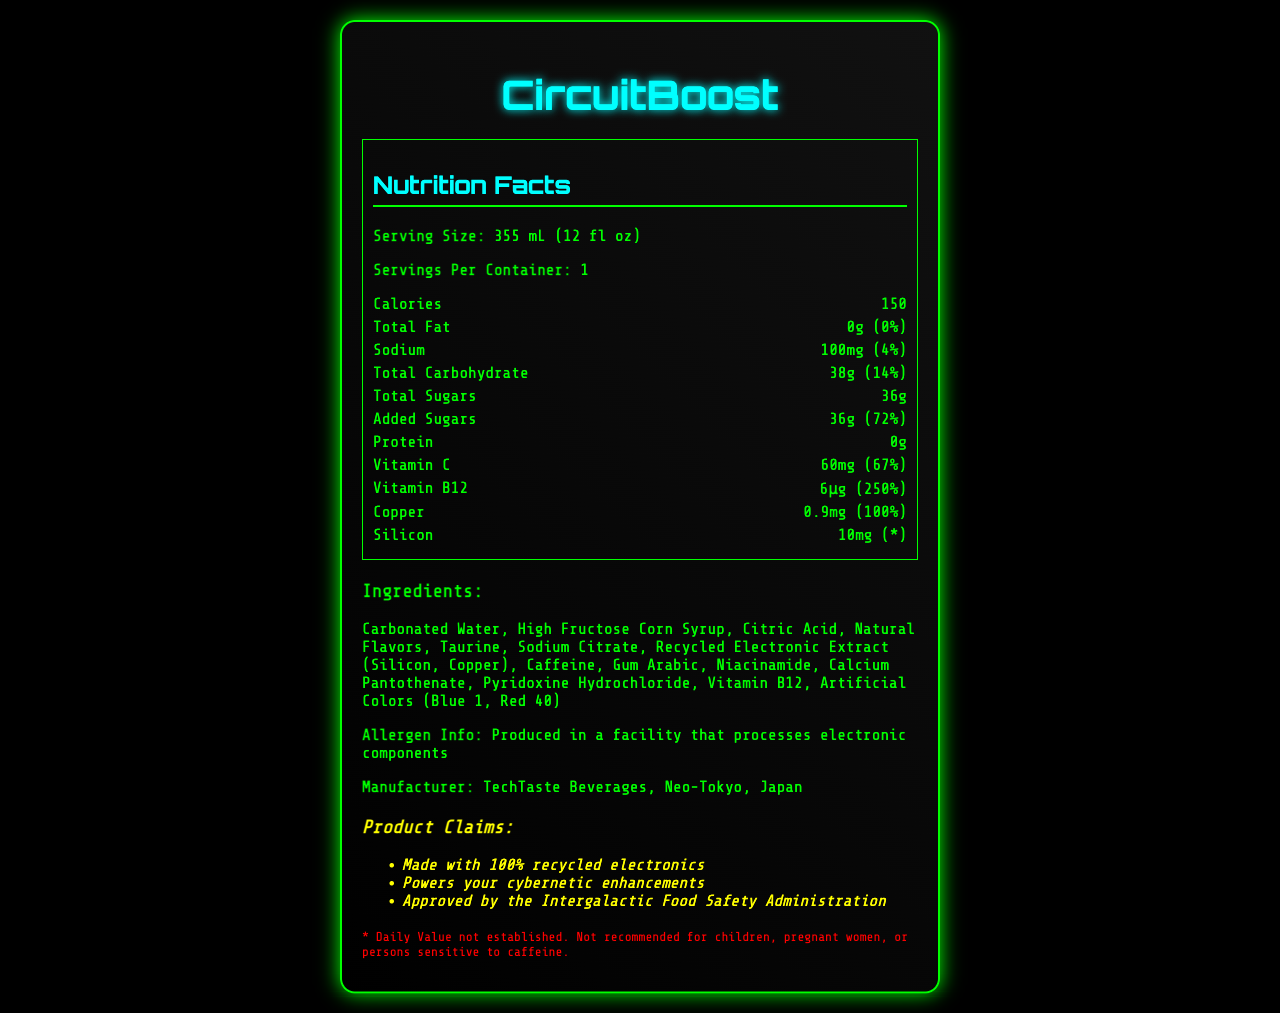what is the serving size of CircuitBoost? The serving size is listed under the nutrition facts section as 355 mL (12 fl oz).
Answer: 355 mL (12 fl oz) how many calories are in one serving of CircuitBoost? The number of calories per serving is listed directly beneath the servings per container in the nutrition facts section.
Answer: 150 what is the daily value percentage of vitamin B12? The daily value percentage for vitamin B12 is listed as 250% in the nutrition facts section.
Answer: 250% how much sodium does one serving contain? The sodium content per serving is listed as 100mg in the nutrition facts section.
Answer: 100mg how much added sugars are in CircuitBoost? The amount of added sugars in CircuitBoost is listed as 36g in the total sugars section of the nutrition facts.
Answer: 36g which of the following ingredients are present in CircuitBoost? A. High Fructose Corn Syrup B. Ascorbic Acid C. Maltodextrin D. Stevia The ingredient list includes High Fructose Corn Syrup but not Ascorbic Acid, Maltodextrin, or Stevia.
Answer: A. High Fructose Corn Syrup what percentage of the daily value for total carbohydrates is provided? A. 4% B. 10% C. 14% D. 20% The daily value percentage for total carbohydrates is listed as 14% in the nutrition facts section.
Answer: C. 14% is CircuitBoost recommended for children? The disclaimer at the bottom of the document specifies that CircuitBoost is not recommended for children, pregnant women, or persons sensitive to caffeine.
Answer: No what claims are made about CircuitBoost? The marketing claims section lists these three claims.
Answer: Made with 100% recycled electronics, Powers your cybernetic enhancements, Approved by the Intergalactic Food Safety Administration summarize the main idea of the document. The document is a detailed nutrition facts label for CircuitBoost, listing serving size, calories, macronutrients, vitamins, minerals, ingredients, allergen info, manufacturer details, marketing claims, and disclaimers.
Answer: The document provides the nutrition facts, ingredients, and marketing claims for CircuitBoost, a futuristic energy drink made from recycled electronics, along with its manufacturer and allergen information. what is the amount of silicon in CircuitBoost? The amount of silicon is listed as 10mg in the nutrition facts section under the minerals.
Answer: 10mg who is the manufacturer of CircuitBoost? The manufacturer is listed at the bottom of the document next to the allergen information.
Answer: TechTaste Beverages, Neo-Tokyo, Japan does CircuitBoost contain any fat? The total fat content is listed as 0g with a daily value of 0% in the nutrition facts section.
Answer: No how many servings are in one container? The number of servings per container is listed as 1 in the nutrition facts section.
Answer: 1 what is the protein content in CircuitBoost? The protein content is listed as 0g in the nutrition facts section.
Answer: 0g where can the production facility process information be found? The allergen information states that the product is produced in a facility that processes electronic components.
Answer: It is mentioned in the allergen information is the amount of copper given in percentages or milligrams? The copper content is listed in milligrams as 0.9mg.
Answer: Milligrams (mg) what is the flavor of CircuitBoost? The document lists ingredients and nutrition facts but does not specify the flavor of CircuitBoost.
Answer: Cannot be determined how much vitamin C is in one serving of CircuitBoost? The amount of vitamin C per serving is listed as 60mg in the nutrition facts section.
Answer: 60mg 